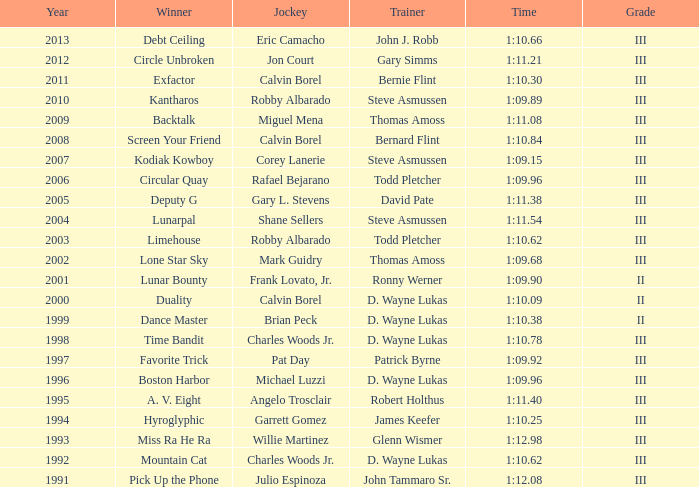What was the period for screen your friend? 1:10.84. 